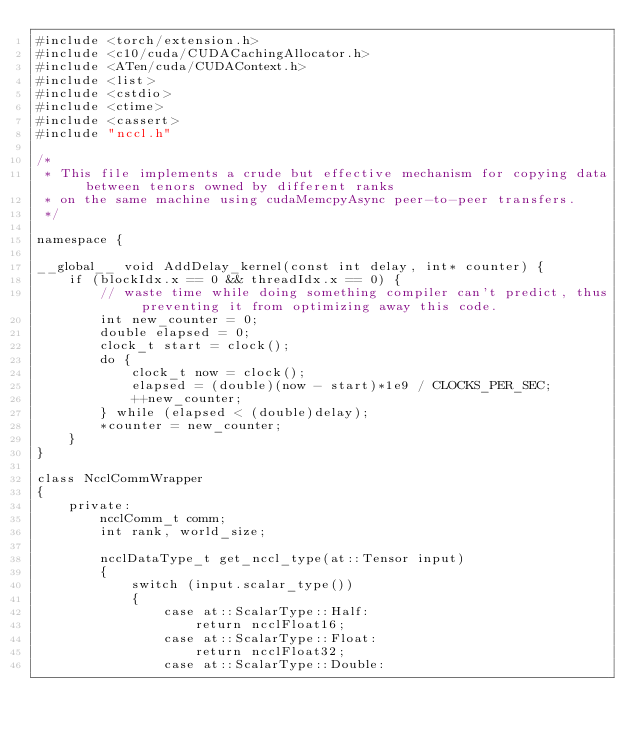<code> <loc_0><loc_0><loc_500><loc_500><_Cuda_>#include <torch/extension.h>
#include <c10/cuda/CUDACachingAllocator.h>
#include <ATen/cuda/CUDAContext.h>
#include <list>
#include <cstdio>
#include <ctime>
#include <cassert>
#include "nccl.h"

/*
 * This file implements a crude but effective mechanism for copying data between tenors owned by different ranks
 * on the same machine using cudaMemcpyAsync peer-to-peer transfers.
 */

namespace {

__global__ void AddDelay_kernel(const int delay, int* counter) {
    if (blockIdx.x == 0 && threadIdx.x == 0) {
        // waste time while doing something compiler can't predict, thus preventing it from optimizing away this code.
        int new_counter = 0;
        double elapsed = 0;
        clock_t start = clock();
        do {
            clock_t now = clock();
            elapsed = (double)(now - start)*1e9 / CLOCKS_PER_SEC;
            ++new_counter;
        } while (elapsed < (double)delay);
        *counter = new_counter;
    }
}

class NcclCommWrapper
{
    private:
        ncclComm_t comm;
        int rank, world_size;

        ncclDataType_t get_nccl_type(at::Tensor input)
        {
            switch (input.scalar_type())
            {
                case at::ScalarType::Half:
                    return ncclFloat16;
                case at::ScalarType::Float:
                    return ncclFloat32;
                case at::ScalarType::Double:</code> 